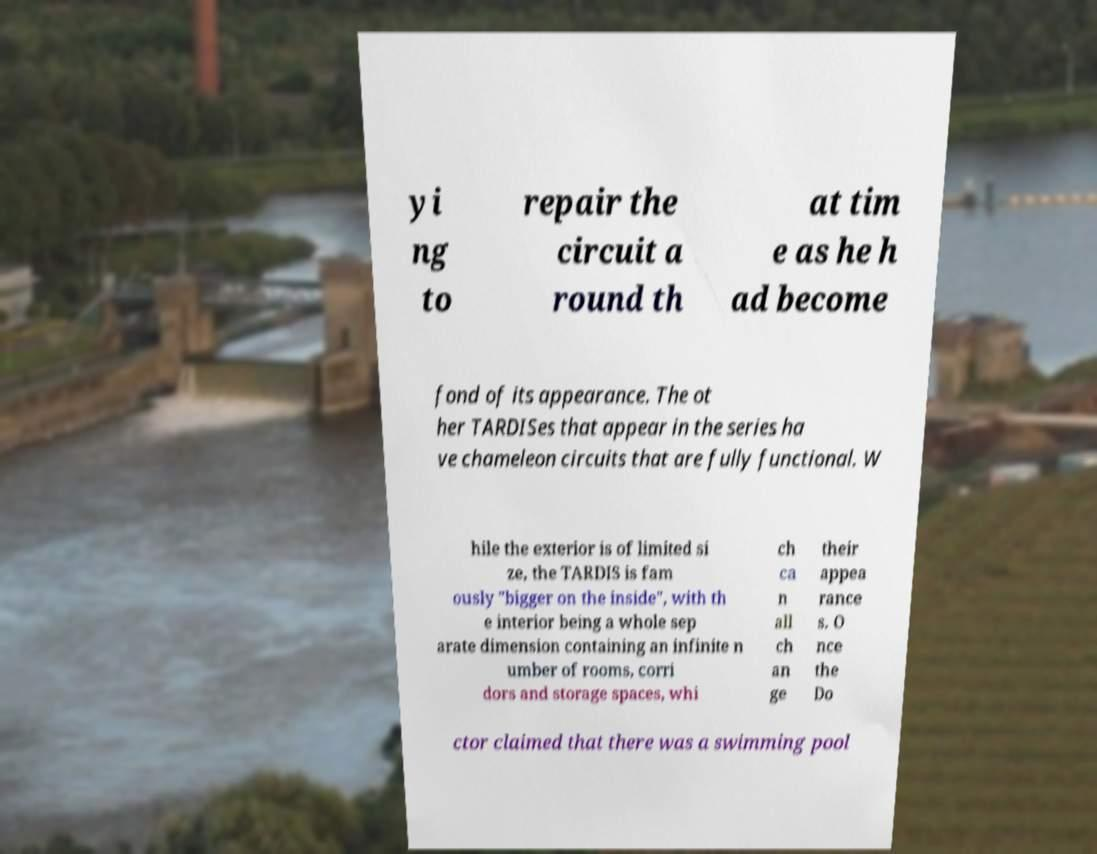Please read and relay the text visible in this image. What does it say? yi ng to repair the circuit a round th at tim e as he h ad become fond of its appearance. The ot her TARDISes that appear in the series ha ve chameleon circuits that are fully functional. W hile the exterior is of limited si ze, the TARDIS is fam ously "bigger on the inside", with th e interior being a whole sep arate dimension containing an infinite n umber of rooms, corri dors and storage spaces, whi ch ca n all ch an ge their appea rance s. O nce the Do ctor claimed that there was a swimming pool 